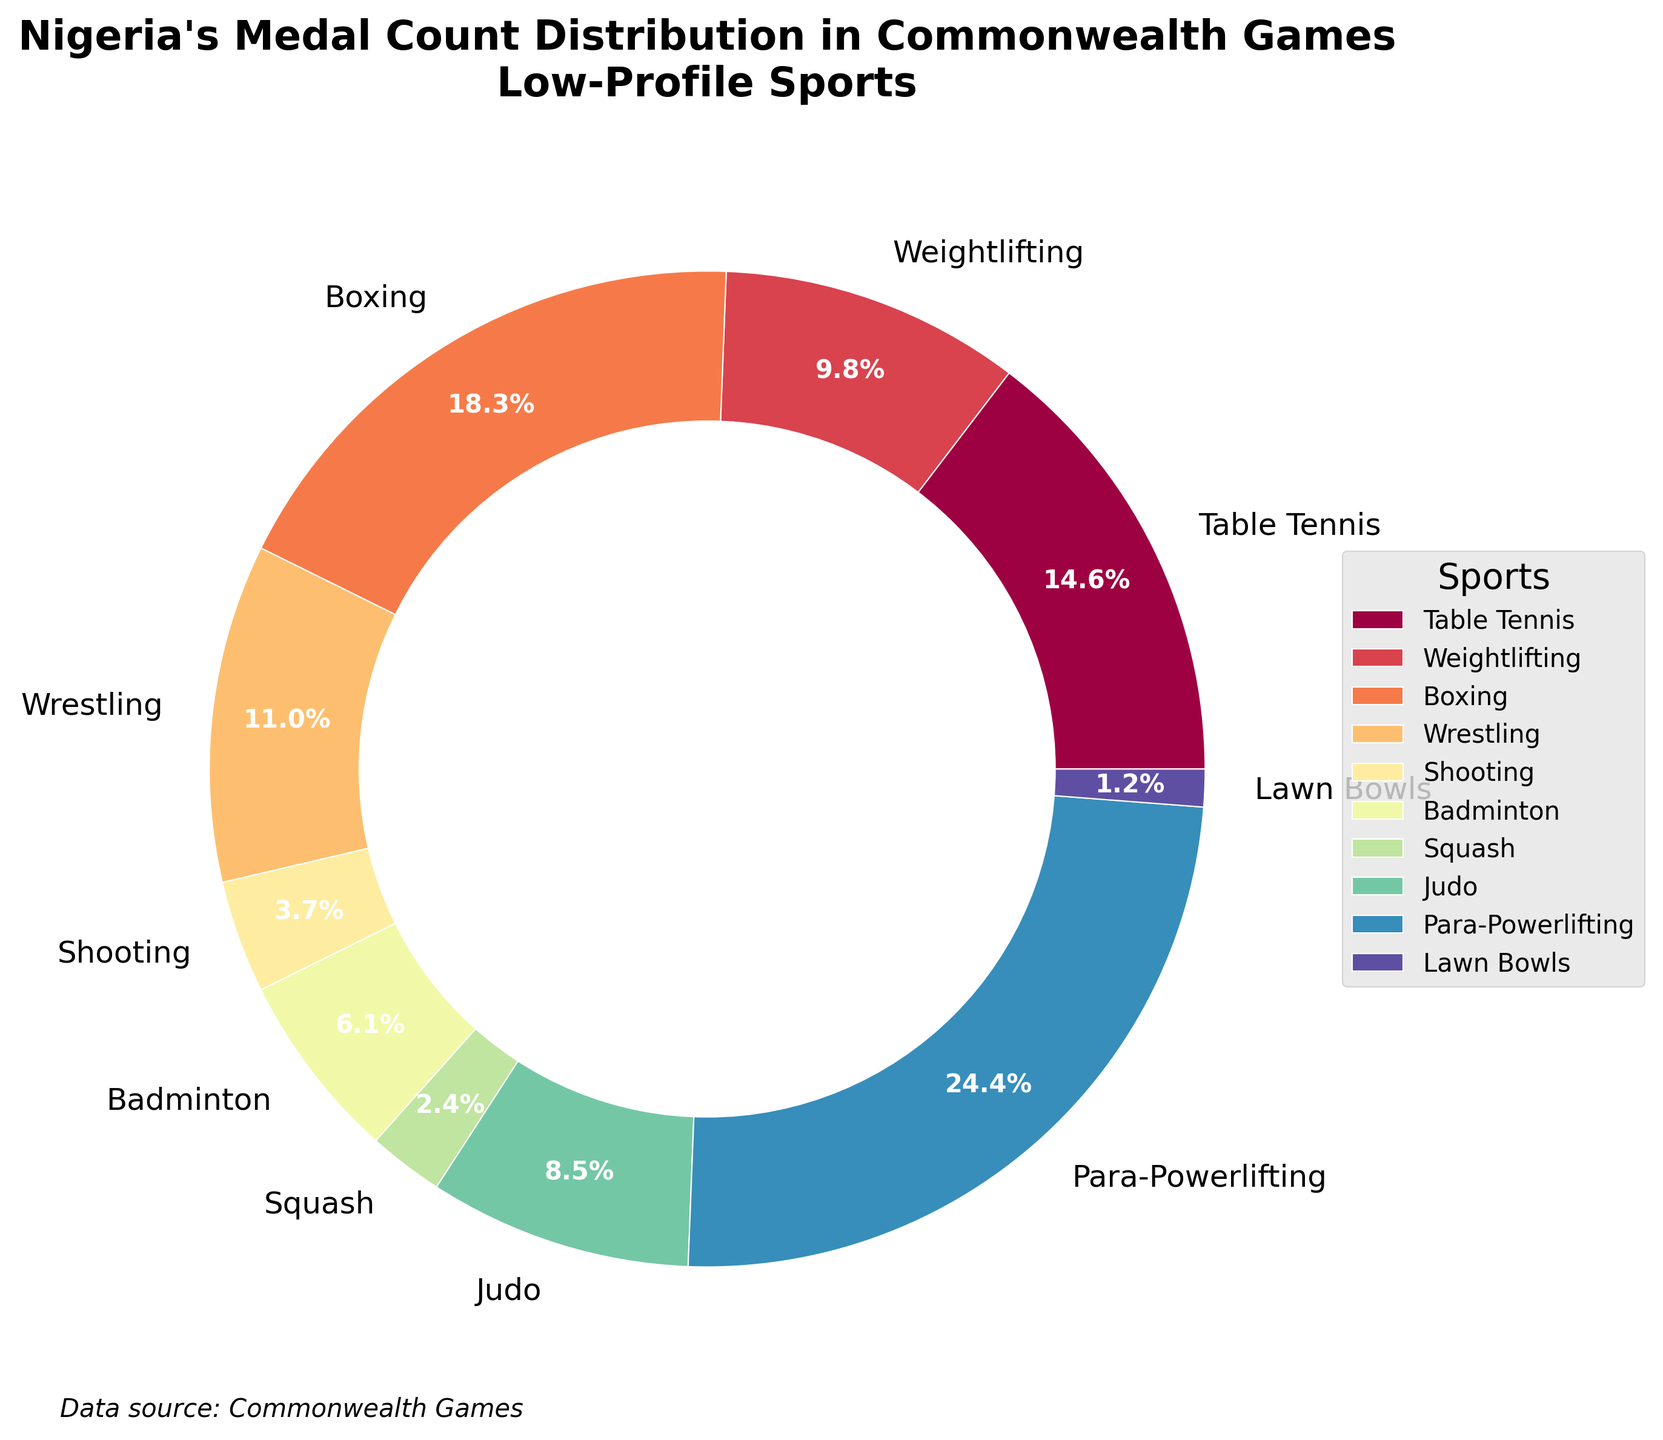Which sport has the highest medal count? By looking at the pie chart, the sport with the largest wedge indicates the highest medal count. Para-Powerlifting occupies the largest wedge.
Answer: Para-Powerlifting Which sport has the lowest medal count? By identifying the smallest wedge in the pie chart, it can be observed that Lawn Bowls has the smallest wedge, indicating the lowest medal count.
Answer: Lawn Bowls How much greater is the medal count for Para-Powerlifting compared to Shooting? Para-Powerlifting has 20 medals and Shooting has 3 medals. The difference is calculated as 20 - 3 = 17.
Answer: 17 Which sport has more medals: Judo or Badminton? From the pie chart, we see that Judo has 7 medals and Badminton has 5 medals. Comparing these values, Judo has more medals.
Answer: Judo What percentage of the total medal count does Boxing contribute? The pie chart shows percentages for each sport. Boxing contributes 15 medals out of a total (12 + 8 + 15 + 9 + 3 + 5 + 2 + 7 + 20 + 1 = 82), which is (15/82) * 100 ≈ 18.3%.
Answer: 18.3% What is the combined medal count for Weightlifting and Wrestling? Weightlifting has 8 medals and Wrestling has 9 medals. Adding these together, 8 + 9 = 17 medals.
Answer: 17 Between Para-Powerlifting and Table Tennis, which has a larger percentage share of the total medal count? The pie chart segments for Para-Powerlifting and Table Tennis show their respective contributions. Para-Powerlifting has 20 medals (24.4%), and Table Tennis has 12 medals (14.6%). Para-Powerlifting has a larger share.
Answer: Para-Powerlifting Which sport’s medal count is closest to the total medal count of Squash and Badminton combined? Squash has 2 medals and Badminton has 5 medals; together, they total 2 + 5 = 7 medals. Judo also has 7 medals, which matches this combined count.
Answer: Judo If the total number of medals was 100, how many medals would Shooting have if its percentage share remained the same? Currently, Shooting contributes 3.7% as indicated by the chart. If total medals are 100, Shooting would have 3.7% of 100, which is 3.7 medals.
Answer: 3.7 